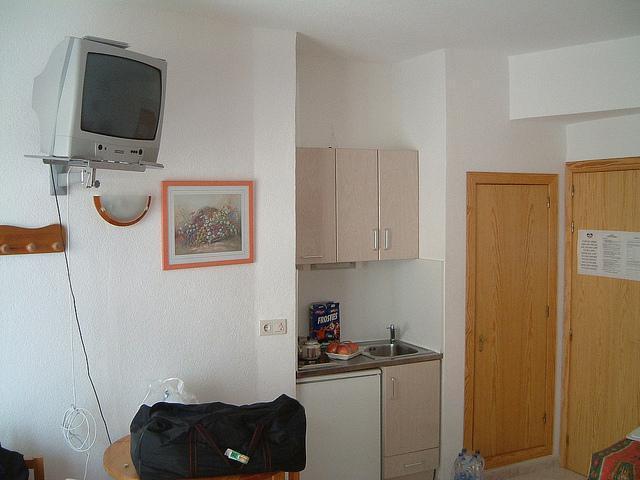How many pink donuts are there?
Give a very brief answer. 0. 